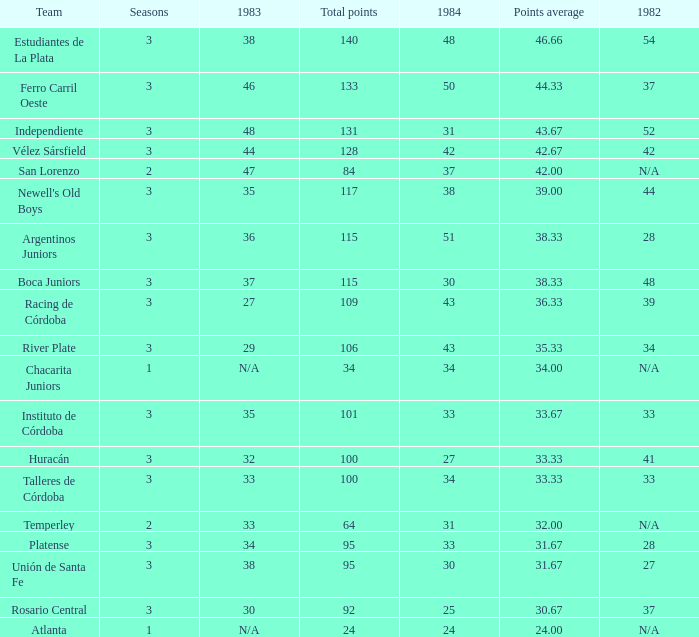What is the points total for the team with points average more than 34, 1984 score more than 37 and N/A in 1982? 0.0. 